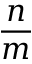<formula> <loc_0><loc_0><loc_500><loc_500>\frac { n } { m }</formula> 